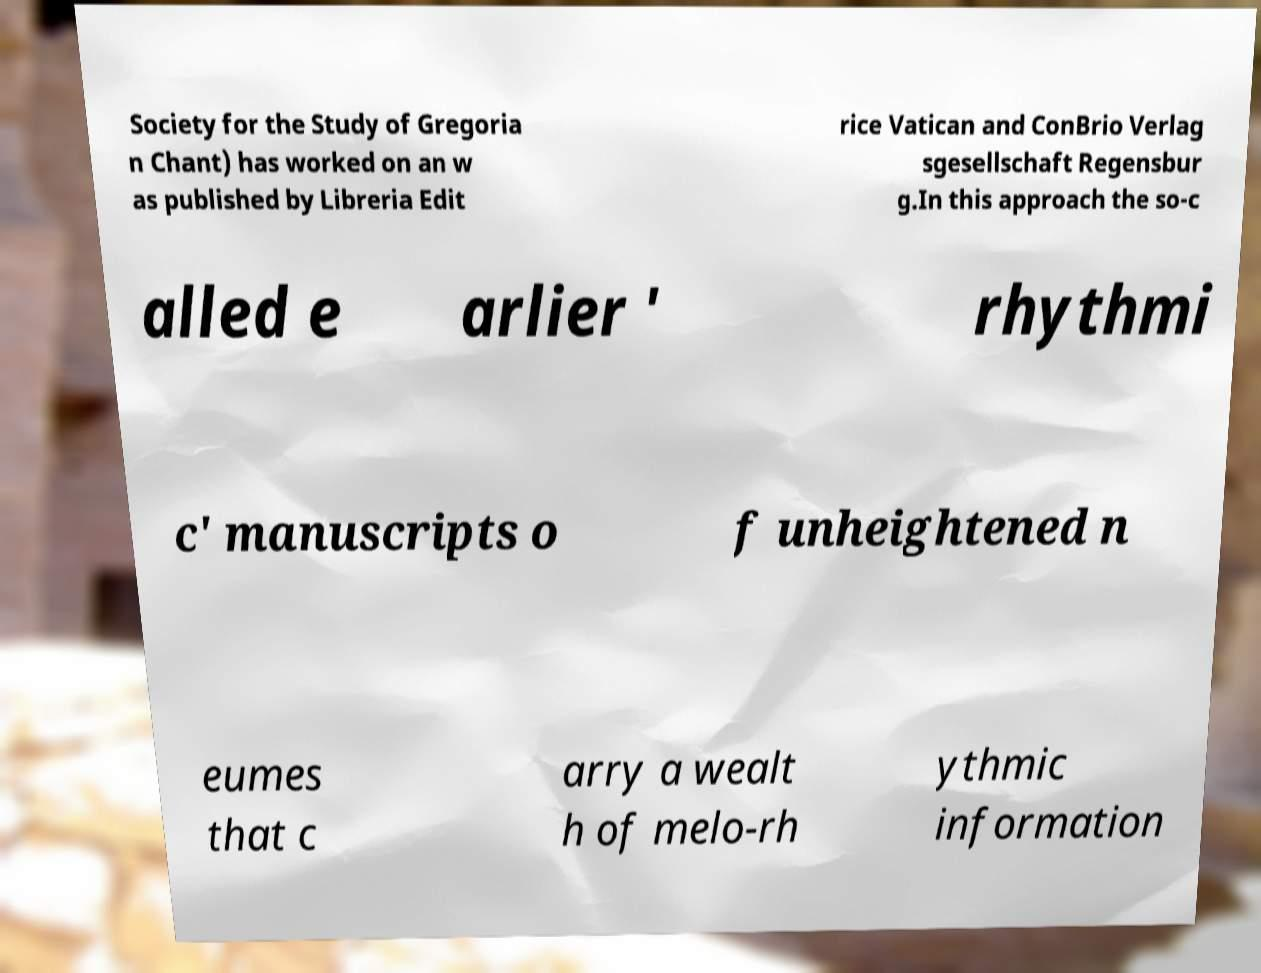There's text embedded in this image that I need extracted. Can you transcribe it verbatim? Society for the Study of Gregoria n Chant) has worked on an w as published by Libreria Edit rice Vatican and ConBrio Verlag sgesellschaft Regensbur g.In this approach the so-c alled e arlier ' rhythmi c' manuscripts o f unheightened n eumes that c arry a wealt h of melo-rh ythmic information 